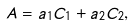Convert formula to latex. <formula><loc_0><loc_0><loc_500><loc_500>A = a _ { 1 } C _ { 1 } + a _ { 2 } C _ { 2 } ,</formula> 